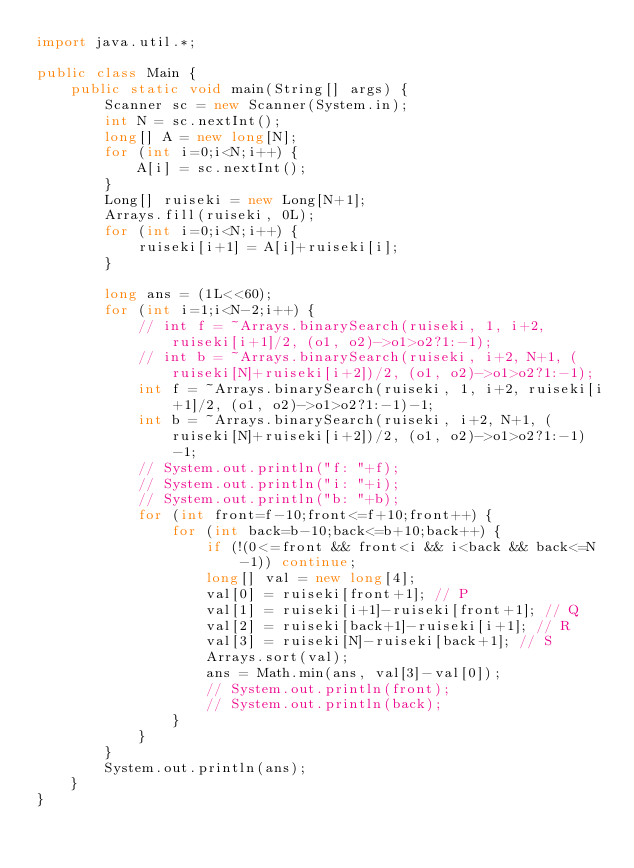Convert code to text. <code><loc_0><loc_0><loc_500><loc_500><_Java_>import java.util.*;

public class Main {
    public static void main(String[] args) {
        Scanner sc = new Scanner(System.in);
        int N = sc.nextInt();
        long[] A = new long[N];
        for (int i=0;i<N;i++) {
            A[i] = sc.nextInt();
        }
        Long[] ruiseki = new Long[N+1];
        Arrays.fill(ruiseki, 0L);
        for (int i=0;i<N;i++) {
            ruiseki[i+1] = A[i]+ruiseki[i];
        }

        long ans = (1L<<60);
        for (int i=1;i<N-2;i++) {
            // int f = ~Arrays.binarySearch(ruiseki, 1, i+2, ruiseki[i+1]/2, (o1, o2)->o1>o2?1:-1);
            // int b = ~Arrays.binarySearch(ruiseki, i+2, N+1, (ruiseki[N]+ruiseki[i+2])/2, (o1, o2)->o1>o2?1:-1);
            int f = ~Arrays.binarySearch(ruiseki, 1, i+2, ruiseki[i+1]/2, (o1, o2)->o1>o2?1:-1)-1;
            int b = ~Arrays.binarySearch(ruiseki, i+2, N+1, (ruiseki[N]+ruiseki[i+2])/2, (o1, o2)->o1>o2?1:-1)-1;
            // System.out.println("f: "+f);
            // System.out.println("i: "+i);
            // System.out.println("b: "+b);
            for (int front=f-10;front<=f+10;front++) {
                for (int back=b-10;back<=b+10;back++) {
                    if (!(0<=front && front<i && i<back && back<=N-1)) continue;
                    long[] val = new long[4];
                    val[0] = ruiseki[front+1]; // P
                    val[1] = ruiseki[i+1]-ruiseki[front+1]; // Q
                    val[2] = ruiseki[back+1]-ruiseki[i+1]; // R
                    val[3] = ruiseki[N]-ruiseki[back+1]; // S
                    Arrays.sort(val);
                    ans = Math.min(ans, val[3]-val[0]);
                    // System.out.println(front);
                    // System.out.println(back);
                }
            }
        }
        System.out.println(ans);
    }
}</code> 